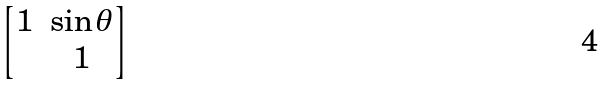<formula> <loc_0><loc_0><loc_500><loc_500>\begin{bmatrix} 1 & \sin \theta \\ & 1 \end{bmatrix}</formula> 